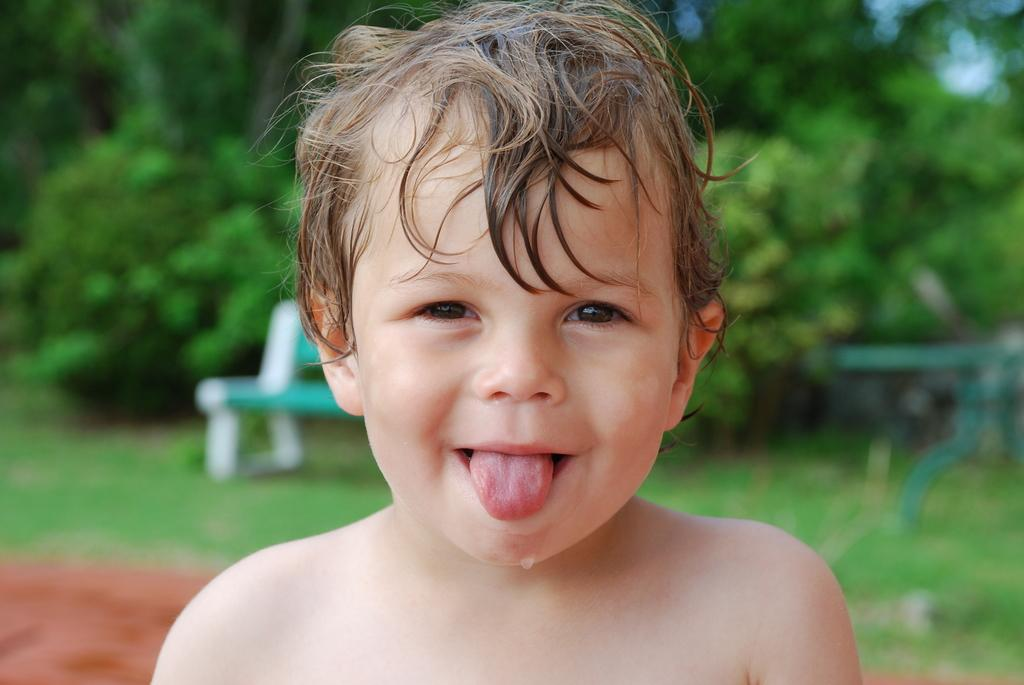Who is present in the image? There is a boy in the image. What is behind the boy? There is a bench behind the boy. What type of natural environment can be seen in the image? Trees are visible in the image. What type of vase is on the bench next to the boy? There is no vase present in the image. 